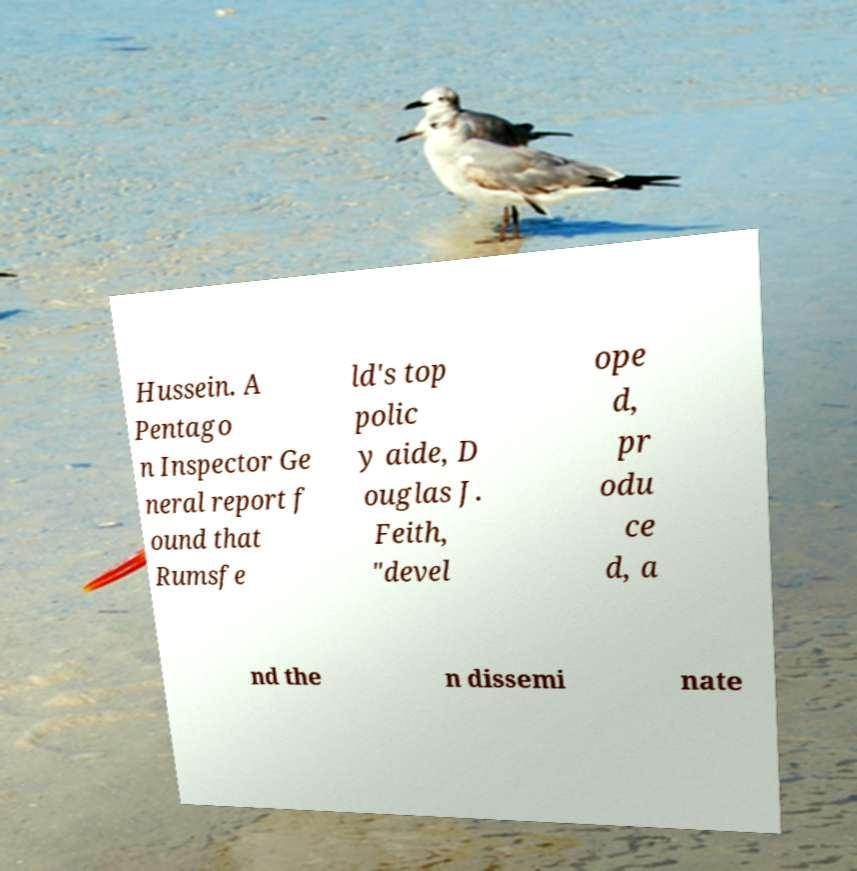Could you assist in decoding the text presented in this image and type it out clearly? Hussein. A Pentago n Inspector Ge neral report f ound that Rumsfe ld's top polic y aide, D ouglas J. Feith, "devel ope d, pr odu ce d, a nd the n dissemi nate 